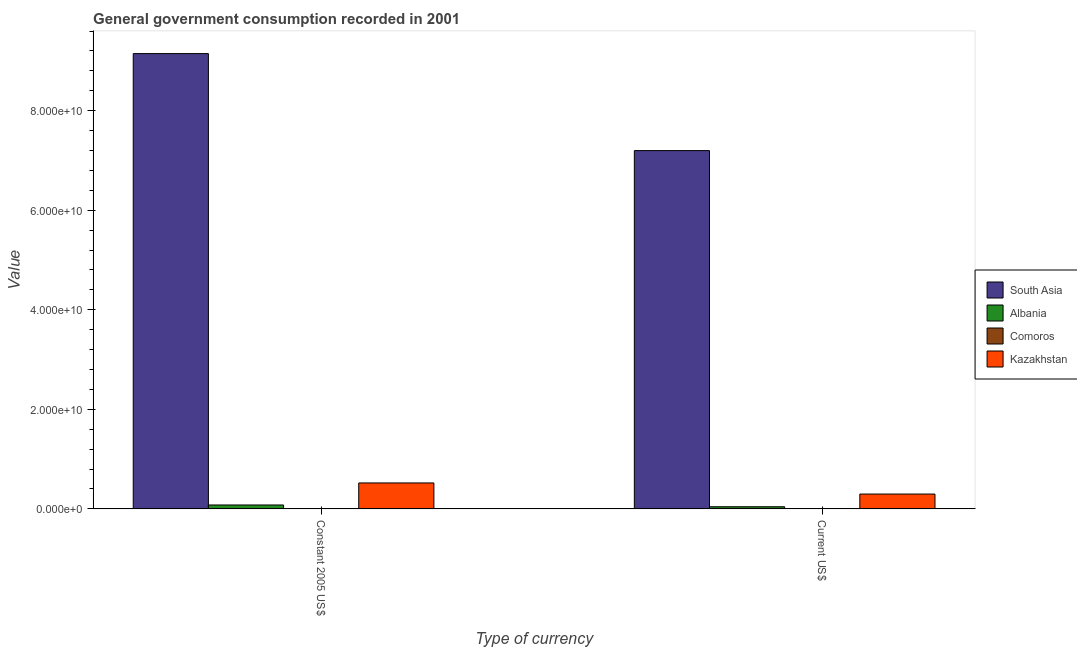How many different coloured bars are there?
Offer a very short reply. 4. Are the number of bars per tick equal to the number of legend labels?
Offer a terse response. Yes. What is the label of the 2nd group of bars from the left?
Ensure brevity in your answer.  Current US$. What is the value consumed in constant 2005 us$ in Comoros?
Your response must be concise. 5.32e+07. Across all countries, what is the maximum value consumed in constant 2005 us$?
Ensure brevity in your answer.  9.15e+1. Across all countries, what is the minimum value consumed in current us$?
Provide a succinct answer. 3.59e+07. In which country was the value consumed in current us$ maximum?
Ensure brevity in your answer.  South Asia. In which country was the value consumed in constant 2005 us$ minimum?
Give a very brief answer. Comoros. What is the total value consumed in current us$ in the graph?
Offer a very short reply. 7.54e+1. What is the difference between the value consumed in current us$ in Kazakhstan and that in Albania?
Give a very brief answer. 2.55e+09. What is the difference between the value consumed in current us$ in Comoros and the value consumed in constant 2005 us$ in South Asia?
Provide a succinct answer. -9.14e+1. What is the average value consumed in current us$ per country?
Give a very brief answer. 1.89e+1. What is the difference between the value consumed in constant 2005 us$ and value consumed in current us$ in Albania?
Offer a very short reply. 3.54e+08. What is the ratio of the value consumed in constant 2005 us$ in Comoros to that in Albania?
Provide a short and direct response. 0.07. Is the value consumed in current us$ in Comoros less than that in South Asia?
Your response must be concise. Yes. What does the 4th bar from the left in Constant 2005 US$ represents?
Your response must be concise. Kazakhstan. How many bars are there?
Your answer should be compact. 8. How many countries are there in the graph?
Offer a very short reply. 4. What is the difference between two consecutive major ticks on the Y-axis?
Ensure brevity in your answer.  2.00e+1. Where does the legend appear in the graph?
Provide a succinct answer. Center right. What is the title of the graph?
Your response must be concise. General government consumption recorded in 2001. What is the label or title of the X-axis?
Offer a very short reply. Type of currency. What is the label or title of the Y-axis?
Give a very brief answer. Value. What is the Value of South Asia in Constant 2005 US$?
Your answer should be very brief. 9.15e+1. What is the Value in Albania in Constant 2005 US$?
Your response must be concise. 7.76e+08. What is the Value of Comoros in Constant 2005 US$?
Give a very brief answer. 5.32e+07. What is the Value of Kazakhstan in Constant 2005 US$?
Provide a succinct answer. 5.21e+09. What is the Value in South Asia in Current US$?
Give a very brief answer. 7.20e+1. What is the Value of Albania in Current US$?
Your response must be concise. 4.22e+08. What is the Value in Comoros in Current US$?
Your response must be concise. 3.59e+07. What is the Value in Kazakhstan in Current US$?
Provide a short and direct response. 2.97e+09. Across all Type of currency, what is the maximum Value in South Asia?
Keep it short and to the point. 9.15e+1. Across all Type of currency, what is the maximum Value of Albania?
Keep it short and to the point. 7.76e+08. Across all Type of currency, what is the maximum Value in Comoros?
Make the answer very short. 5.32e+07. Across all Type of currency, what is the maximum Value in Kazakhstan?
Your answer should be compact. 5.21e+09. Across all Type of currency, what is the minimum Value of South Asia?
Your answer should be compact. 7.20e+1. Across all Type of currency, what is the minimum Value of Albania?
Offer a very short reply. 4.22e+08. Across all Type of currency, what is the minimum Value of Comoros?
Your response must be concise. 3.59e+07. Across all Type of currency, what is the minimum Value in Kazakhstan?
Provide a succinct answer. 2.97e+09. What is the total Value in South Asia in the graph?
Your response must be concise. 1.63e+11. What is the total Value of Albania in the graph?
Your answer should be compact. 1.20e+09. What is the total Value of Comoros in the graph?
Provide a succinct answer. 8.91e+07. What is the total Value in Kazakhstan in the graph?
Your answer should be very brief. 8.18e+09. What is the difference between the Value in South Asia in Constant 2005 US$ and that in Current US$?
Your response must be concise. 1.95e+1. What is the difference between the Value in Albania in Constant 2005 US$ and that in Current US$?
Your answer should be very brief. 3.54e+08. What is the difference between the Value of Comoros in Constant 2005 US$ and that in Current US$?
Make the answer very short. 1.73e+07. What is the difference between the Value of Kazakhstan in Constant 2005 US$ and that in Current US$?
Offer a terse response. 2.23e+09. What is the difference between the Value of South Asia in Constant 2005 US$ and the Value of Albania in Current US$?
Keep it short and to the point. 9.10e+1. What is the difference between the Value of South Asia in Constant 2005 US$ and the Value of Comoros in Current US$?
Make the answer very short. 9.14e+1. What is the difference between the Value in South Asia in Constant 2005 US$ and the Value in Kazakhstan in Current US$?
Your response must be concise. 8.85e+1. What is the difference between the Value of Albania in Constant 2005 US$ and the Value of Comoros in Current US$?
Make the answer very short. 7.40e+08. What is the difference between the Value in Albania in Constant 2005 US$ and the Value in Kazakhstan in Current US$?
Offer a terse response. -2.20e+09. What is the difference between the Value in Comoros in Constant 2005 US$ and the Value in Kazakhstan in Current US$?
Offer a very short reply. -2.92e+09. What is the average Value in South Asia per Type of currency?
Keep it short and to the point. 8.17e+1. What is the average Value of Albania per Type of currency?
Your response must be concise. 5.99e+08. What is the average Value in Comoros per Type of currency?
Your response must be concise. 4.45e+07. What is the average Value of Kazakhstan per Type of currency?
Make the answer very short. 4.09e+09. What is the difference between the Value in South Asia and Value in Albania in Constant 2005 US$?
Provide a short and direct response. 9.07e+1. What is the difference between the Value in South Asia and Value in Comoros in Constant 2005 US$?
Make the answer very short. 9.14e+1. What is the difference between the Value in South Asia and Value in Kazakhstan in Constant 2005 US$?
Your response must be concise. 8.63e+1. What is the difference between the Value in Albania and Value in Comoros in Constant 2005 US$?
Offer a very short reply. 7.23e+08. What is the difference between the Value of Albania and Value of Kazakhstan in Constant 2005 US$?
Provide a succinct answer. -4.43e+09. What is the difference between the Value in Comoros and Value in Kazakhstan in Constant 2005 US$?
Give a very brief answer. -5.15e+09. What is the difference between the Value of South Asia and Value of Albania in Current US$?
Offer a very short reply. 7.16e+1. What is the difference between the Value of South Asia and Value of Comoros in Current US$?
Provide a short and direct response. 7.19e+1. What is the difference between the Value in South Asia and Value in Kazakhstan in Current US$?
Your response must be concise. 6.90e+1. What is the difference between the Value in Albania and Value in Comoros in Current US$?
Offer a terse response. 3.86e+08. What is the difference between the Value of Albania and Value of Kazakhstan in Current US$?
Offer a terse response. -2.55e+09. What is the difference between the Value in Comoros and Value in Kazakhstan in Current US$?
Provide a short and direct response. -2.94e+09. What is the ratio of the Value in South Asia in Constant 2005 US$ to that in Current US$?
Your response must be concise. 1.27. What is the ratio of the Value of Albania in Constant 2005 US$ to that in Current US$?
Provide a short and direct response. 1.84. What is the ratio of the Value of Comoros in Constant 2005 US$ to that in Current US$?
Your answer should be compact. 1.48. What is the ratio of the Value in Kazakhstan in Constant 2005 US$ to that in Current US$?
Keep it short and to the point. 1.75. What is the difference between the highest and the second highest Value in South Asia?
Your answer should be very brief. 1.95e+1. What is the difference between the highest and the second highest Value in Albania?
Offer a very short reply. 3.54e+08. What is the difference between the highest and the second highest Value of Comoros?
Your answer should be compact. 1.73e+07. What is the difference between the highest and the second highest Value in Kazakhstan?
Provide a short and direct response. 2.23e+09. What is the difference between the highest and the lowest Value of South Asia?
Offer a terse response. 1.95e+1. What is the difference between the highest and the lowest Value in Albania?
Keep it short and to the point. 3.54e+08. What is the difference between the highest and the lowest Value in Comoros?
Provide a succinct answer. 1.73e+07. What is the difference between the highest and the lowest Value in Kazakhstan?
Give a very brief answer. 2.23e+09. 